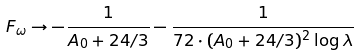<formula> <loc_0><loc_0><loc_500><loc_500>F _ { \omega } \to - \frac { 1 } { A _ { 0 } + 2 4 / 3 } - \frac { 1 } { 7 2 \cdot ( A _ { 0 } + 2 4 / 3 ) ^ { 2 } \log { \lambda } }</formula> 